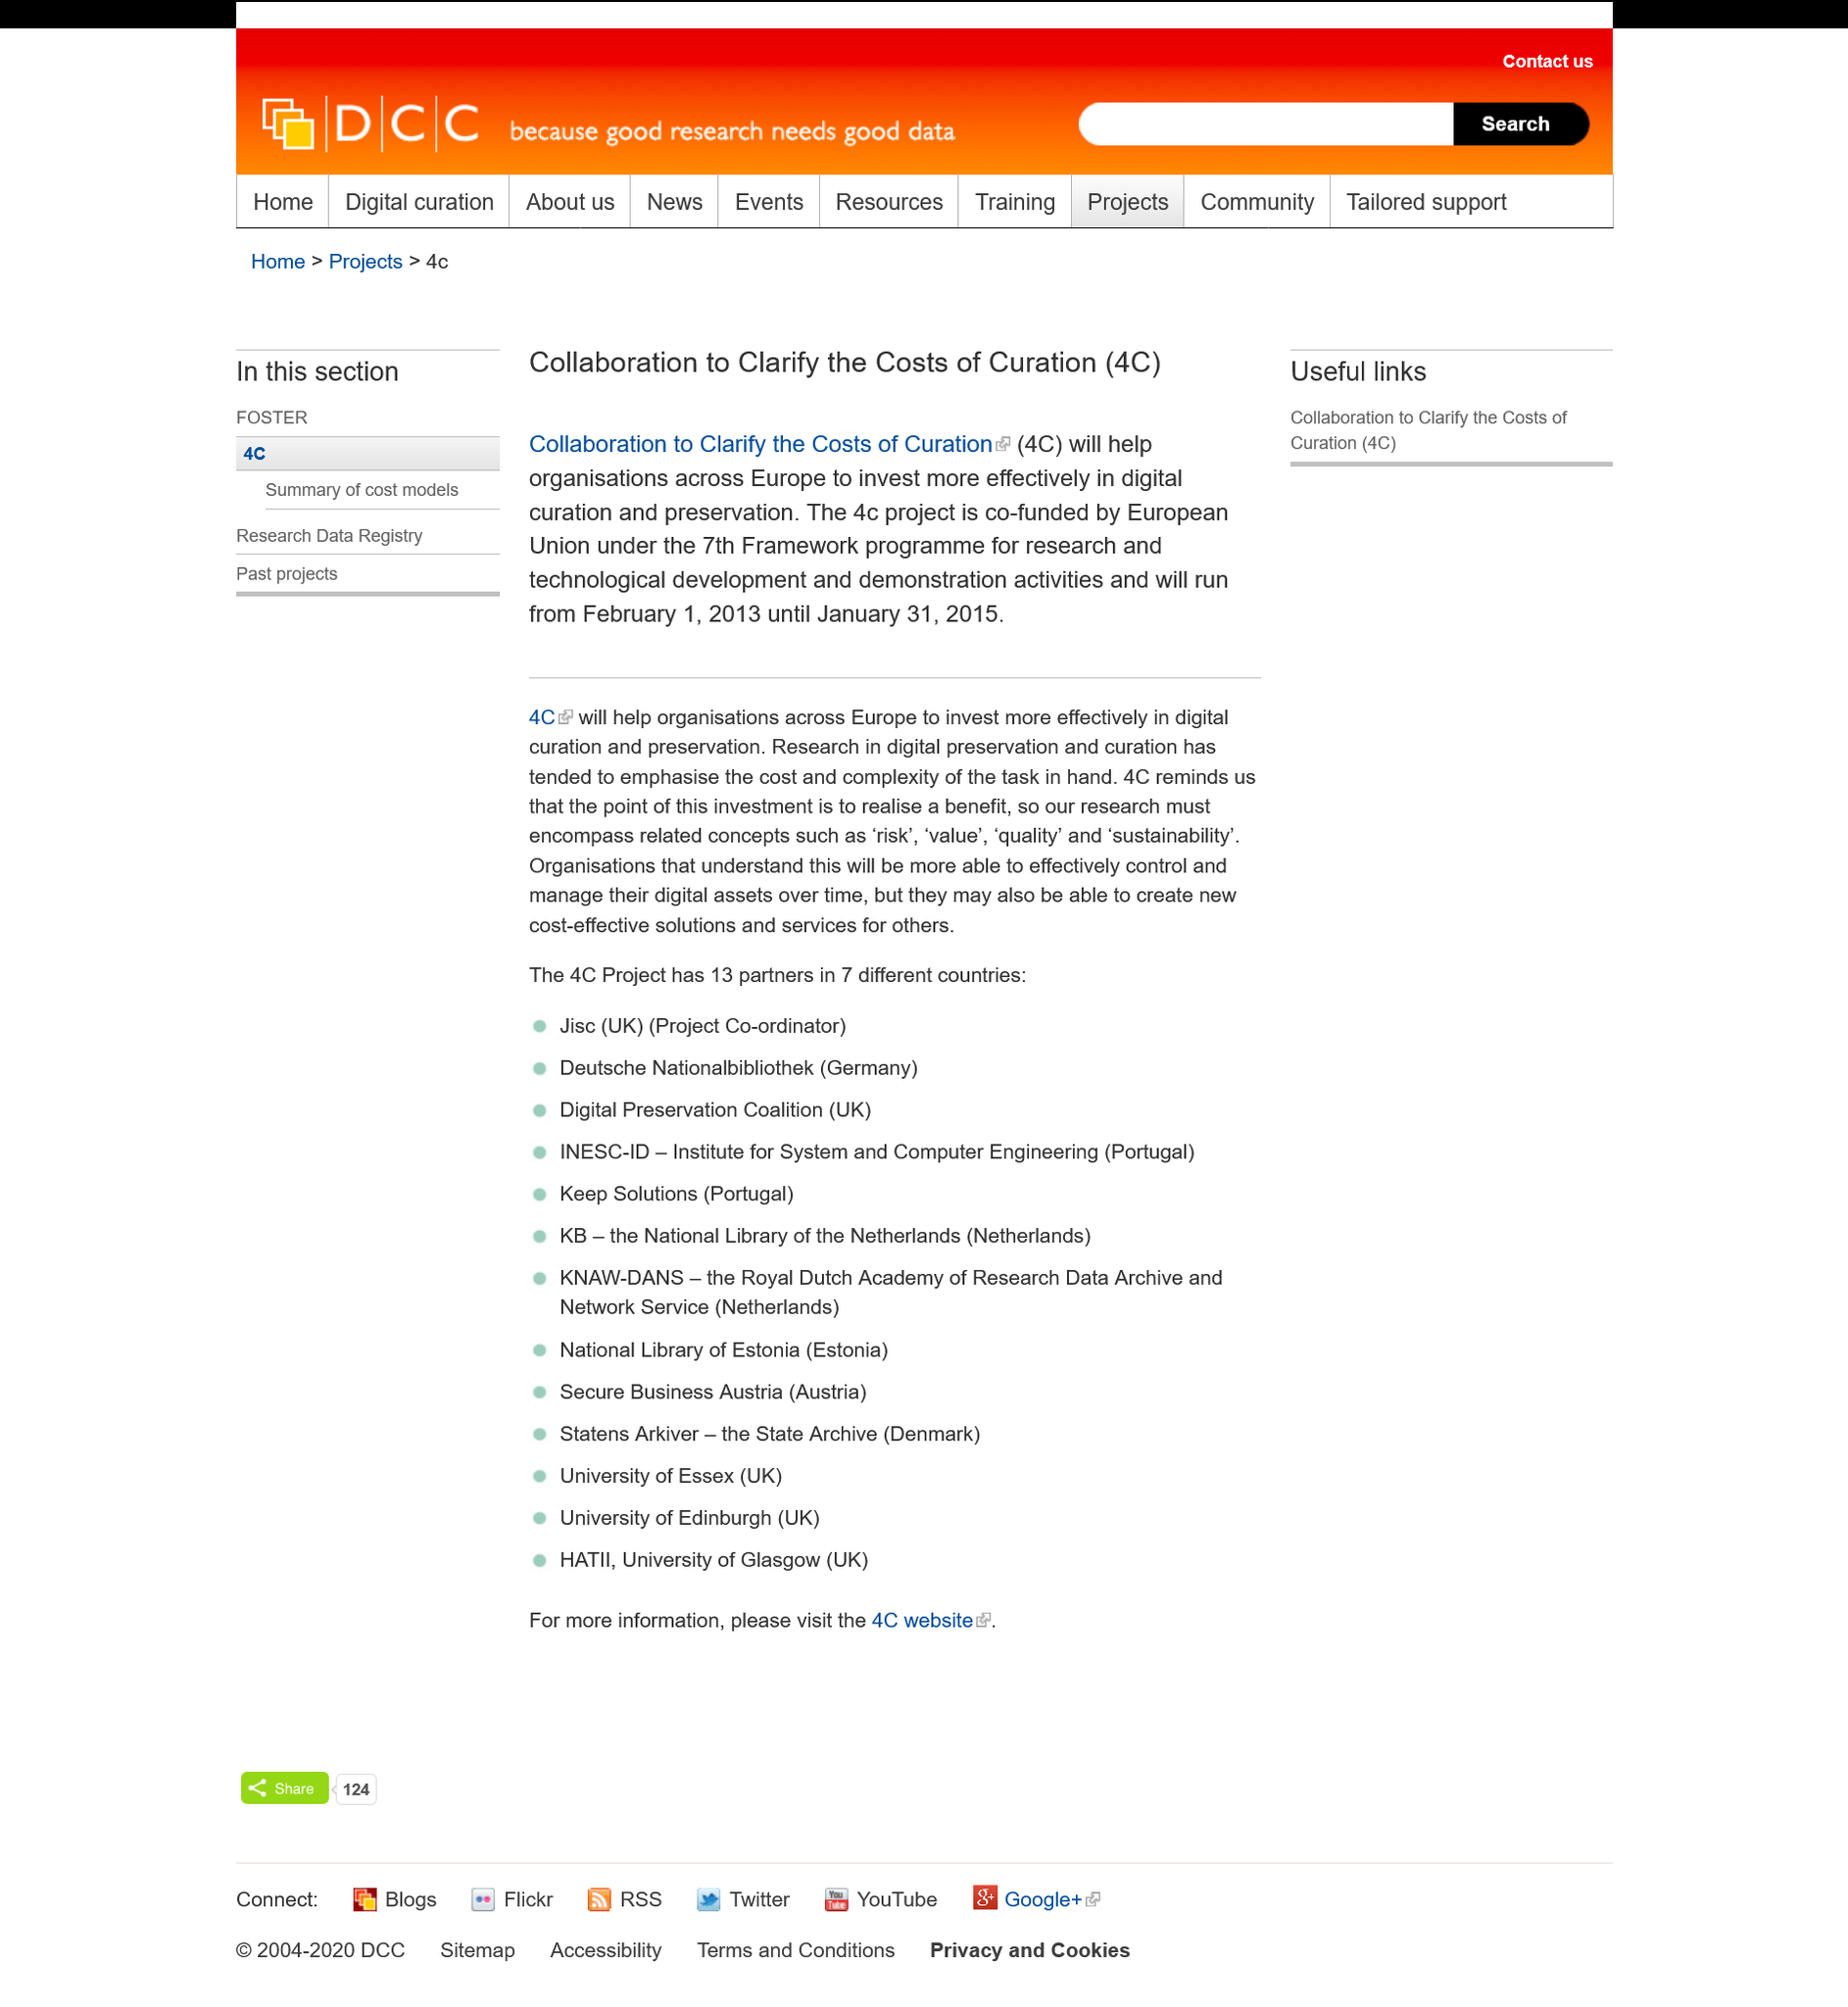Identify some key points in this picture. The 4C project was co-funded by the European Union. The acronym 4C stands for 'Collaboration to Clarify the Costs of Curation'. The 4C project will run from February 1, 2013, to January 31, 2015. 